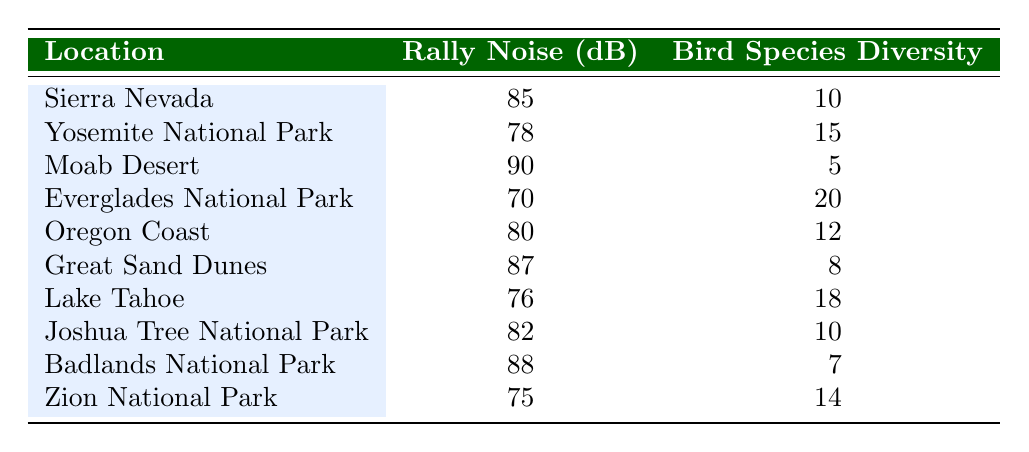What is the rally noise level in Yosemite National Park? Referring to the table, the row for Yosemite National Park indicates the rally noise level is 78 dB.
Answer: 78 dB Which location has the highest bird species diversity index? By examining the table, the Everglades National Park has the highest bird species diversity index with a value of 20.
Answer: Everglades National Park What is the average rally noise level across all locations? The rally noise levels are 85, 78, 90, 70, 80, 87, 76, 82, 88, and 75. Adding these together gives a total of 830, and dividing by 10 (the number of locations) results in an average of 83 dB.
Answer: 83 dB Is the rally noise level in Moab Desert greater than 85 dB? Checking the table, the rally noise level for Moab Desert is 90 dB, which is indeed greater than 85 dB.
Answer: Yes What is the difference in the bird species diversity index between Great Sand Dunes and Lake Tahoe? The bird species diversity index for Great Sand Dunes is 8 and for Lake Tahoe is 18. The difference is calculated as 18 - 8 = 10.
Answer: 10 How many locations have a rally noise level less than 80 dB? Reviewing the table, the locations with rally noise levels below 80 dB are the Everglades National Park (70 dB), Yosemite National Park (78 dB), and Lake Tahoe (76 dB). This gives a total of 3 locations.
Answer: 3 What is the sum of the bird species diversity index for locations with rally noise levels above 85 dB? The locations with rally noise levels above 85 dB are Sierra Nevada (10), Moab Desert (5), Great Sand Dunes (8), and Badlands National Park (7). The sum of their bird species diversity indices is 10 + 5 + 8 + 7 = 30.
Answer: 30 Which location shows a decrease in bird species diversity index as the rally noise level increases? Comparing the data, Moab Desert has a high rally noise level (90 dB) and low bird species diversity (5). In contrast, the Everglades National Park has a low rally noise level (70 dB) and high diversity (20). This trend indicates a decrease in diversity as noise level increases.
Answer: Yes What is the maximum rally noise level recorded among these locations? The table indicates the highest rally noise level is found in the Moab Desert at 90 dB.
Answer: 90 dB 